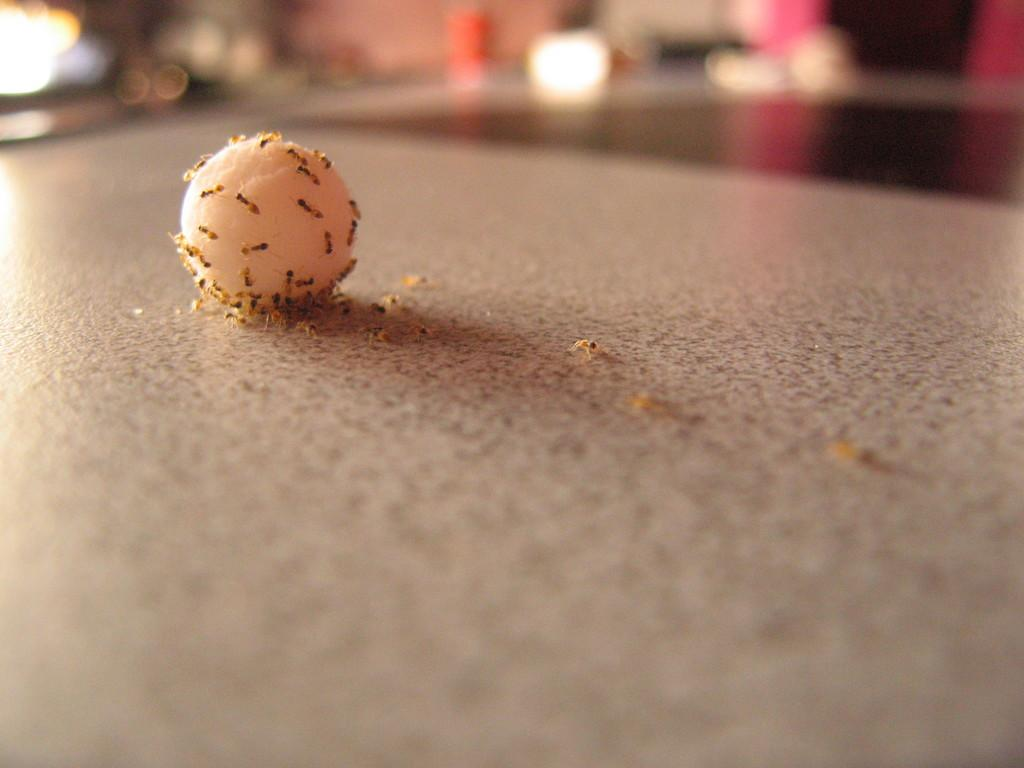What is at the bottom of the image? The image contains a floor at the bottom. What can be found in the image besides the floor? There is food and ants present in the image. Can you describe the background of the image? The background of the image is blurry. What type of pot is visible in the background of the image? There is no pot present in the image; it only contains food and ants. How does the image provide shade for the ants? The image does not provide shade for the ants, as it is a static, two-dimensional representation. 